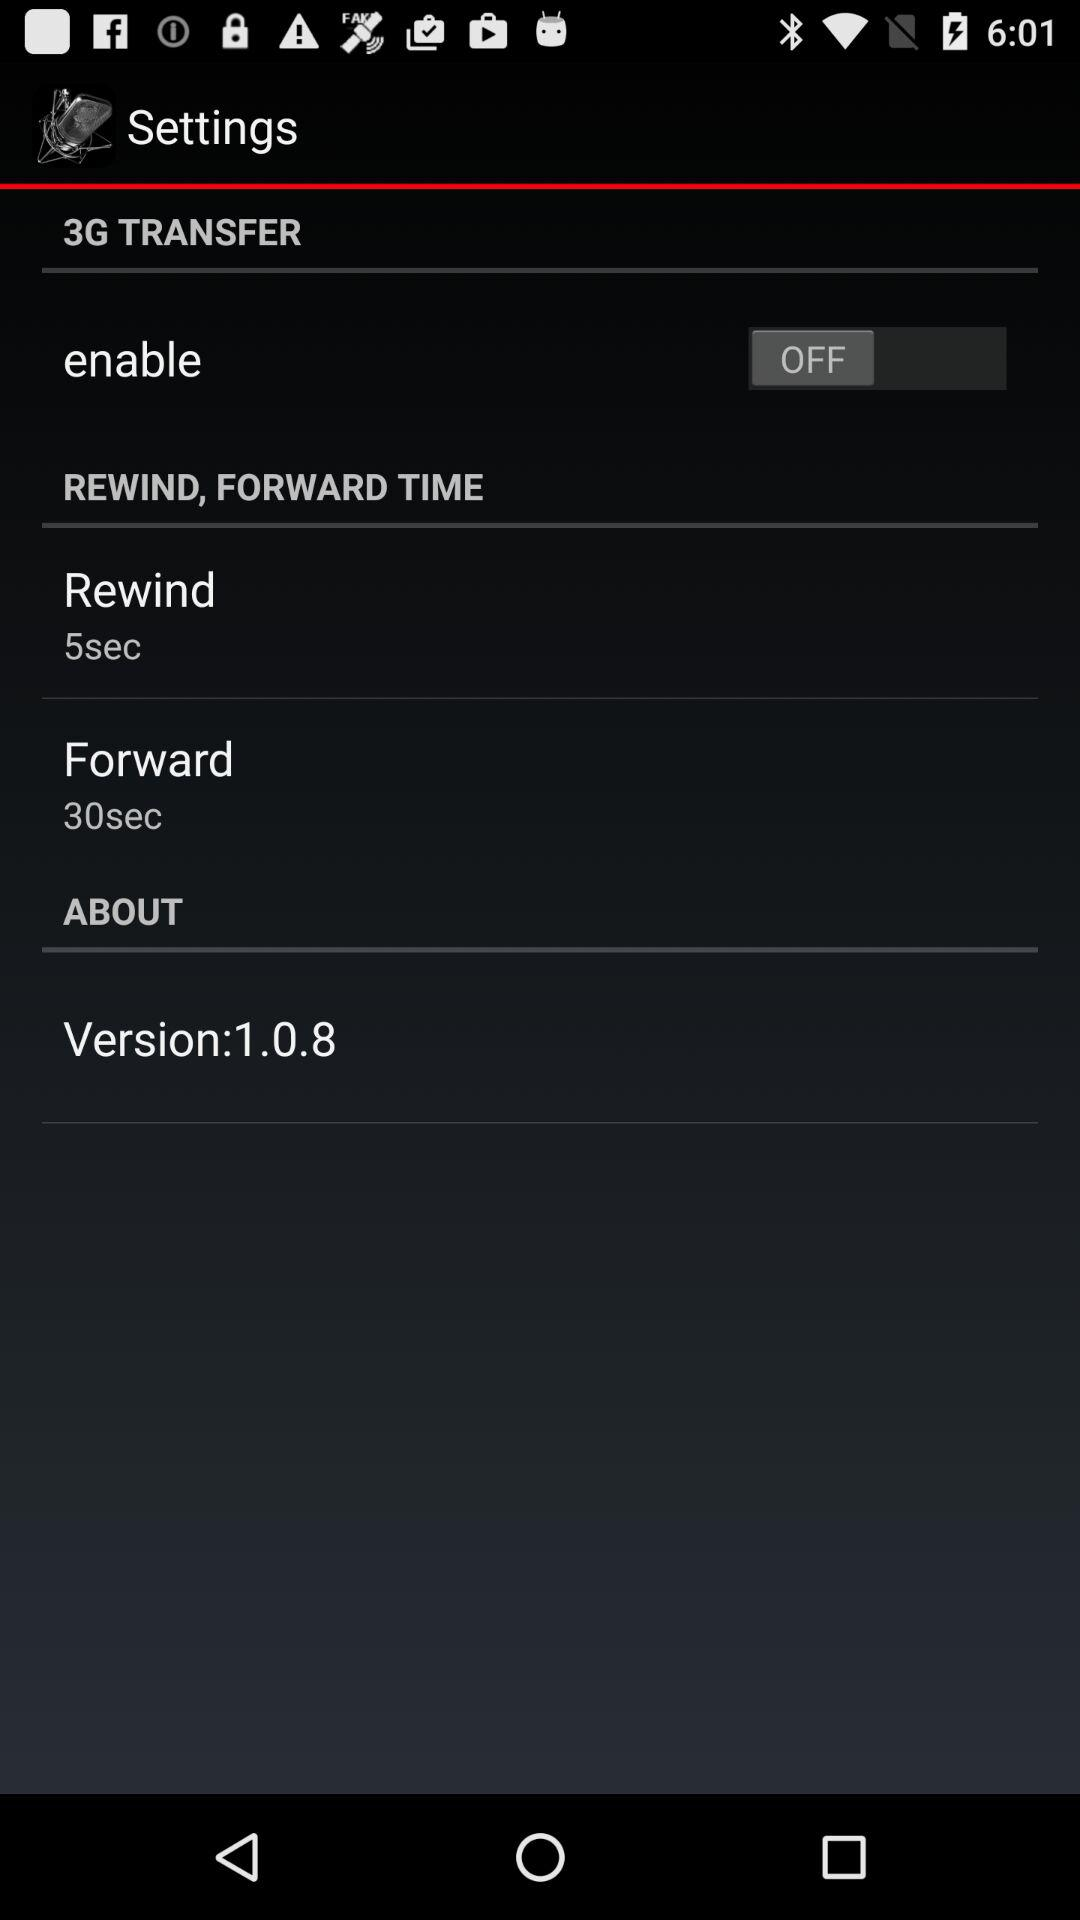What is the version? The version is 1.0.8. 